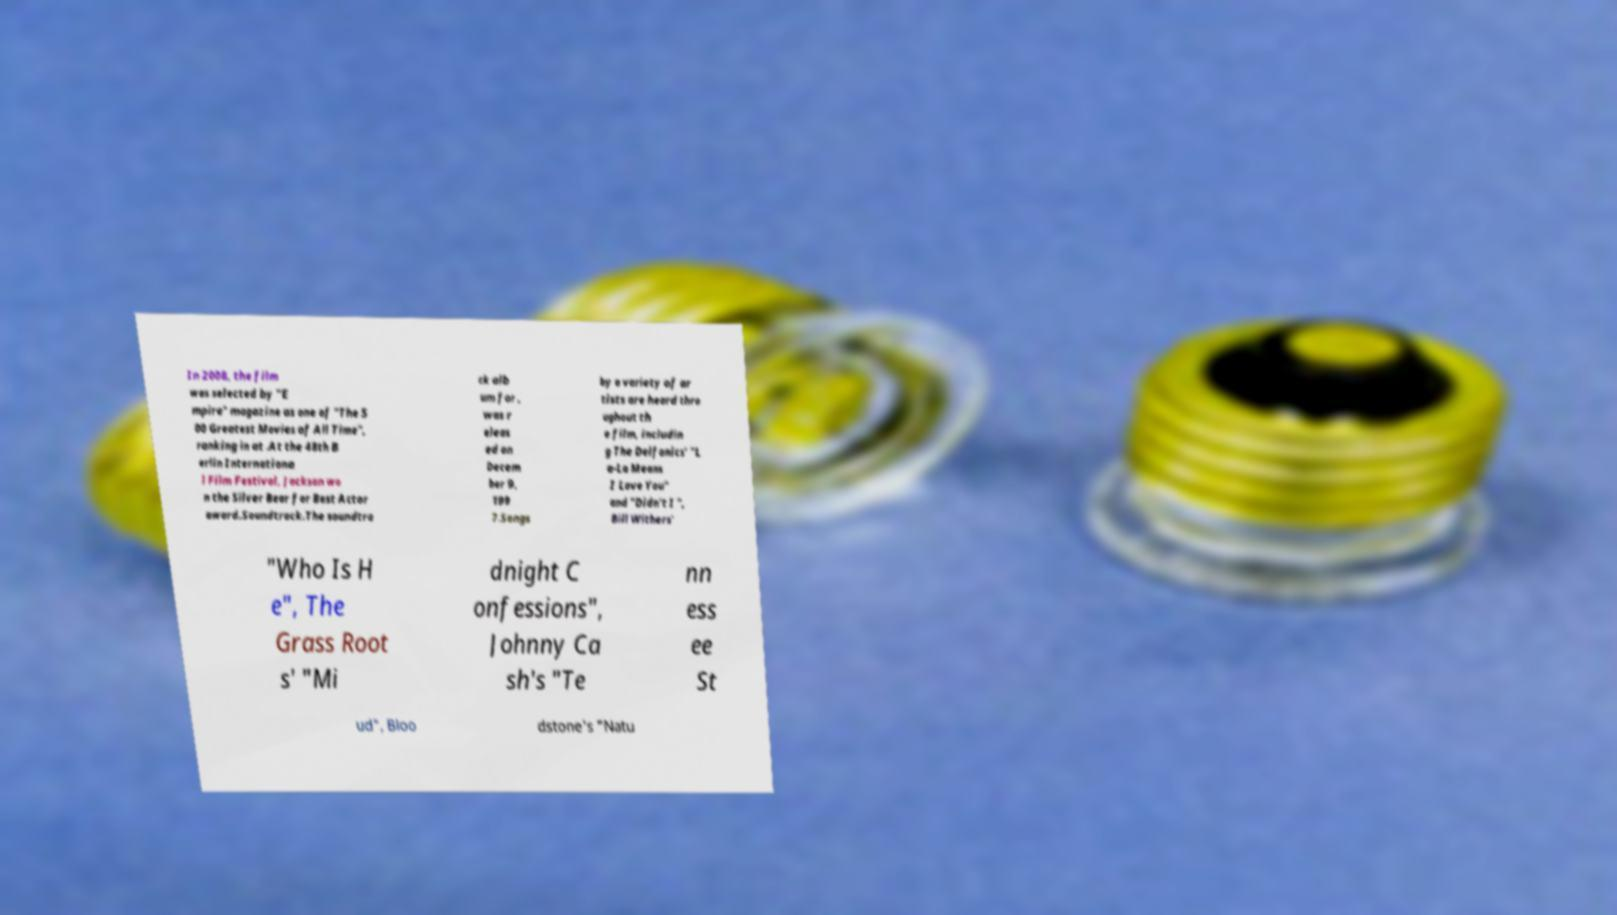Please read and relay the text visible in this image. What does it say? In 2008, the film was selected by "E mpire" magazine as one of "The 5 00 Greatest Movies of All Time", ranking in at .At the 48th B erlin Internationa l Film Festival, Jackson wo n the Silver Bear for Best Actor award.Soundtrack.The soundtra ck alb um for , was r eleas ed on Decem ber 9, 199 7.Songs by a variety of ar tists are heard thro ughout th e film, includin g The Delfonics' "L a-La Means I Love You" and "Didn't I ", Bill Withers' "Who Is H e", The Grass Root s' "Mi dnight C onfessions", Johnny Ca sh's "Te nn ess ee St ud", Bloo dstone's "Natu 